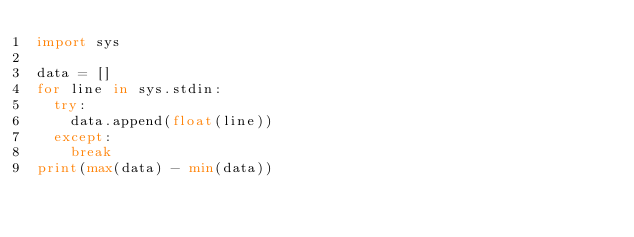Convert code to text. <code><loc_0><loc_0><loc_500><loc_500><_Python_>import sys

data = []
for line in sys.stdin:
  try:
    data.append(float(line))
  except:
    break
print(max(data) - min(data))</code> 